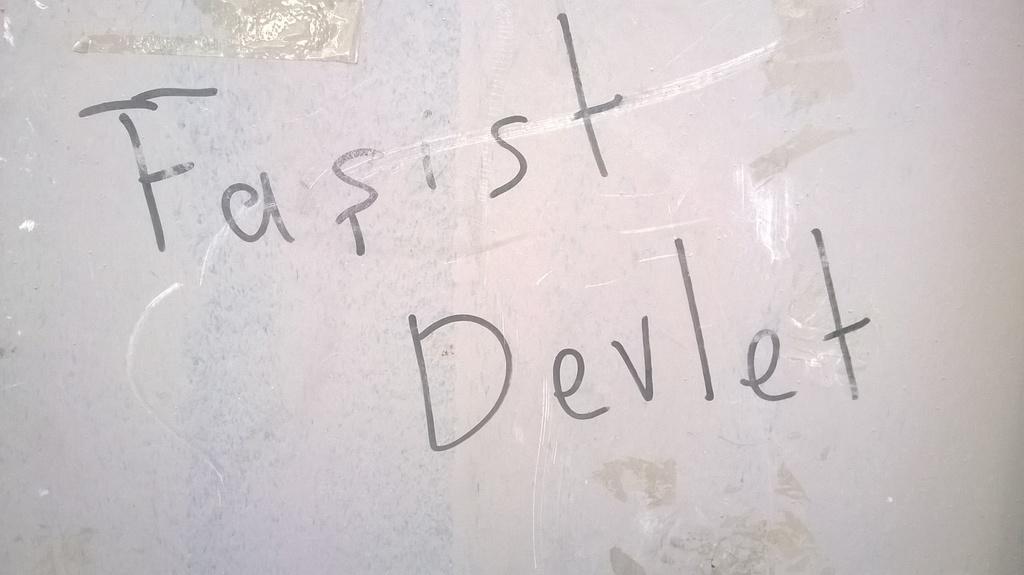What does the text say?
Make the answer very short. Fasist devlet. 